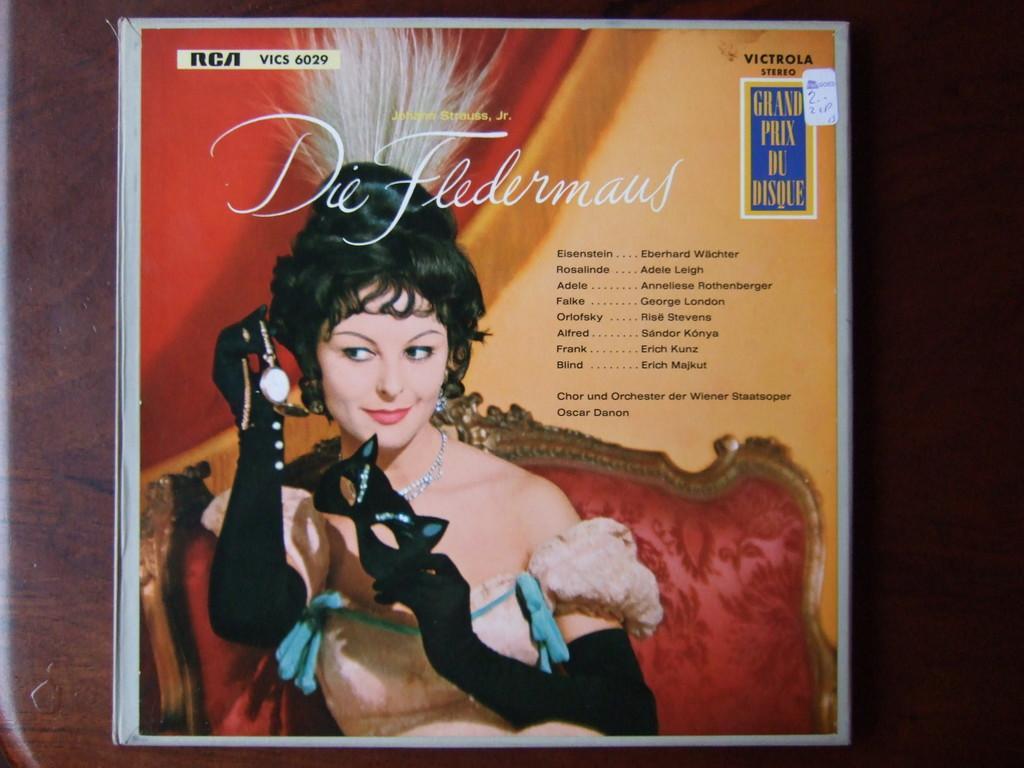How would you summarize this image in a sentence or two? In this picture we can see a poster on a surface and on this poster we can see a woman sitting on a chair and smiling, mask, watch and some text. 